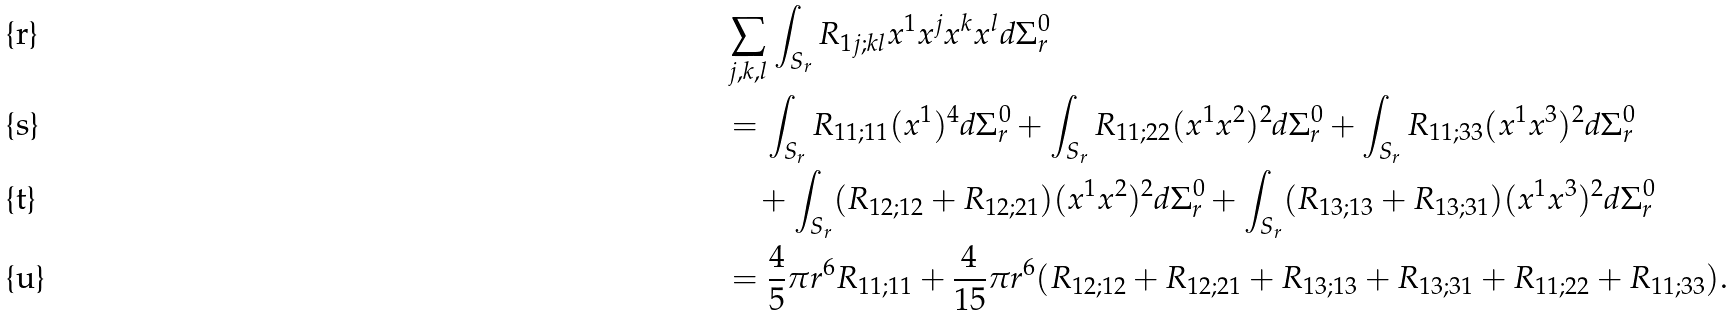Convert formula to latex. <formula><loc_0><loc_0><loc_500><loc_500>& \sum _ { j , k , l } \int _ { S _ { r } } R _ { 1 j ; k l } x ^ { 1 } x ^ { j } x ^ { k } x ^ { l } d \Sigma _ { r } ^ { 0 } \\ & = \int _ { S _ { r } } R _ { 1 1 ; 1 1 } ( x ^ { 1 } ) ^ { 4 } d \Sigma _ { r } ^ { 0 } + \int _ { S _ { r } } R _ { 1 1 ; 2 2 } ( x ^ { 1 } x ^ { 2 } ) ^ { 2 } d \Sigma _ { r } ^ { 0 } + \int _ { S _ { r } } R _ { 1 1 ; 3 3 } ( x ^ { 1 } x ^ { 3 } ) ^ { 2 } d \Sigma _ { r } ^ { 0 } \\ & \quad + \int _ { S _ { r } } ( R _ { 1 2 ; 1 2 } + R _ { 1 2 ; 2 1 } ) ( x ^ { 1 } x ^ { 2 } ) ^ { 2 } d \Sigma _ { r } ^ { 0 } + \int _ { S _ { r } } ( R _ { 1 3 ; 1 3 } + R _ { 1 3 ; 3 1 } ) ( x ^ { 1 } x ^ { 3 } ) ^ { 2 } d \Sigma _ { r } ^ { 0 } \\ & = \frac { 4 } { 5 } \pi r ^ { 6 } R _ { 1 1 ; 1 1 } + \frac { 4 } { 1 5 } \pi r ^ { 6 } ( R _ { 1 2 ; 1 2 } + R _ { 1 2 ; 2 1 } + R _ { 1 3 ; 1 3 } + R _ { 1 3 ; 3 1 } + R _ { 1 1 ; 2 2 } + R _ { 1 1 ; 3 3 } ) .</formula> 